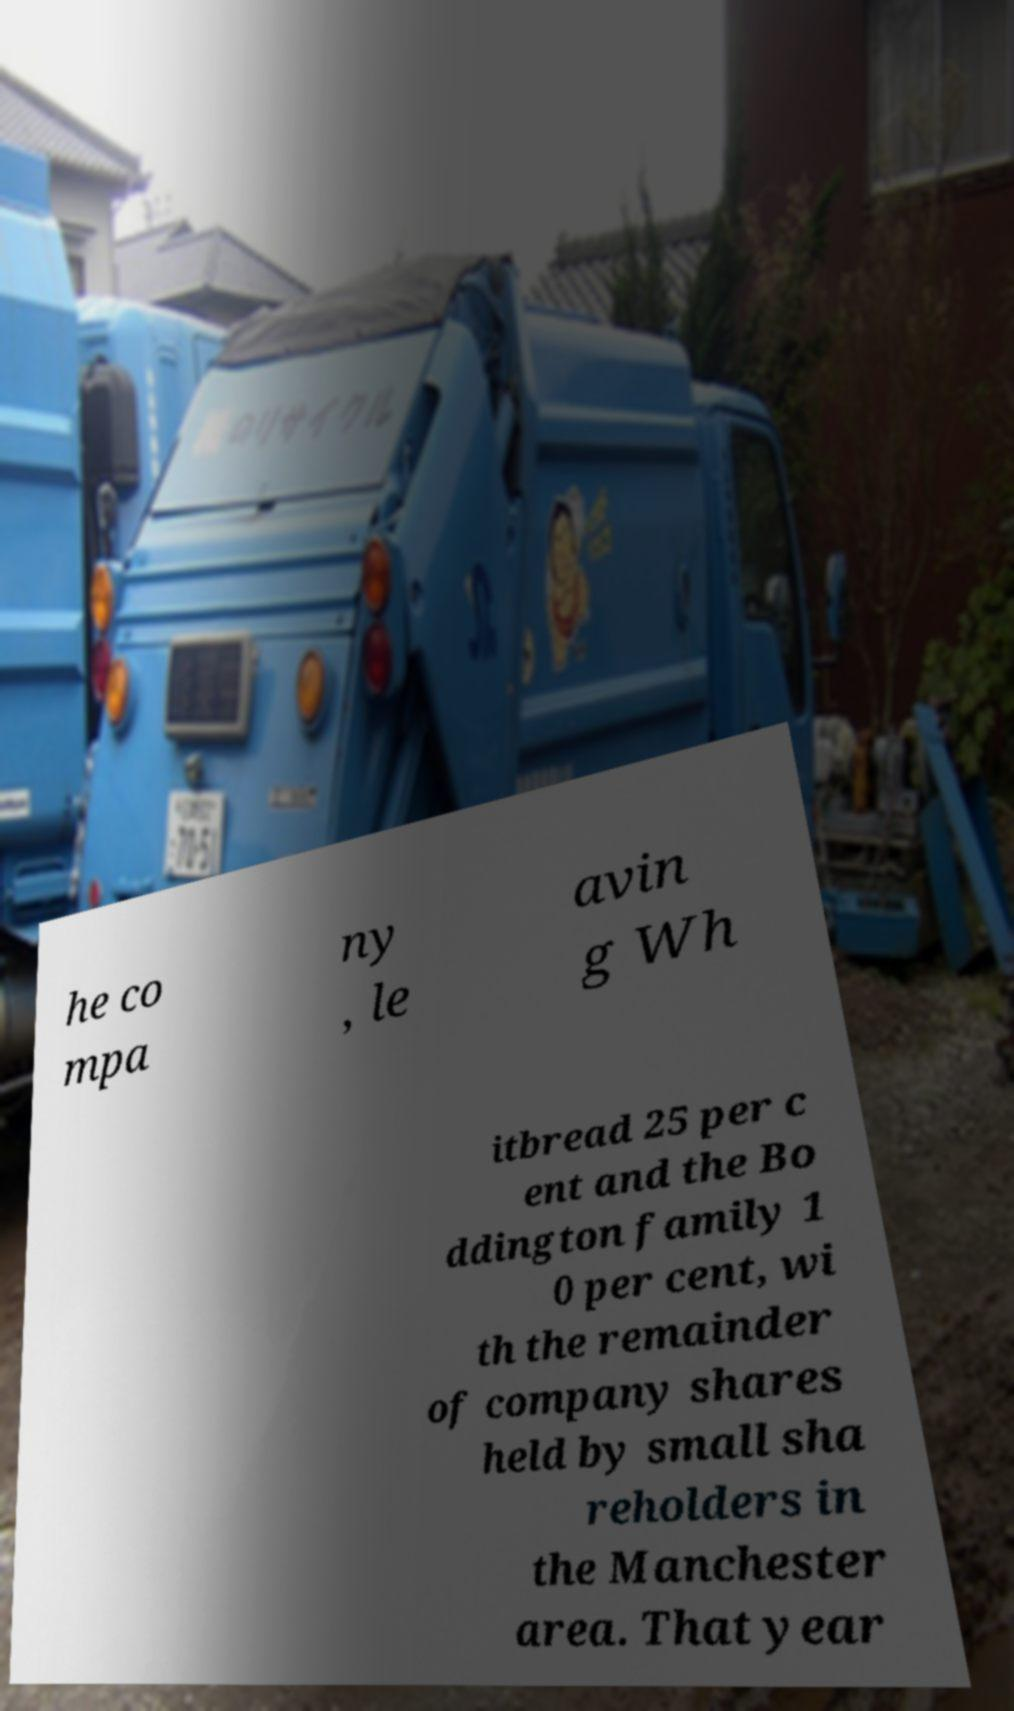Can you accurately transcribe the text from the provided image for me? he co mpa ny , le avin g Wh itbread 25 per c ent and the Bo ddington family 1 0 per cent, wi th the remainder of company shares held by small sha reholders in the Manchester area. That year 